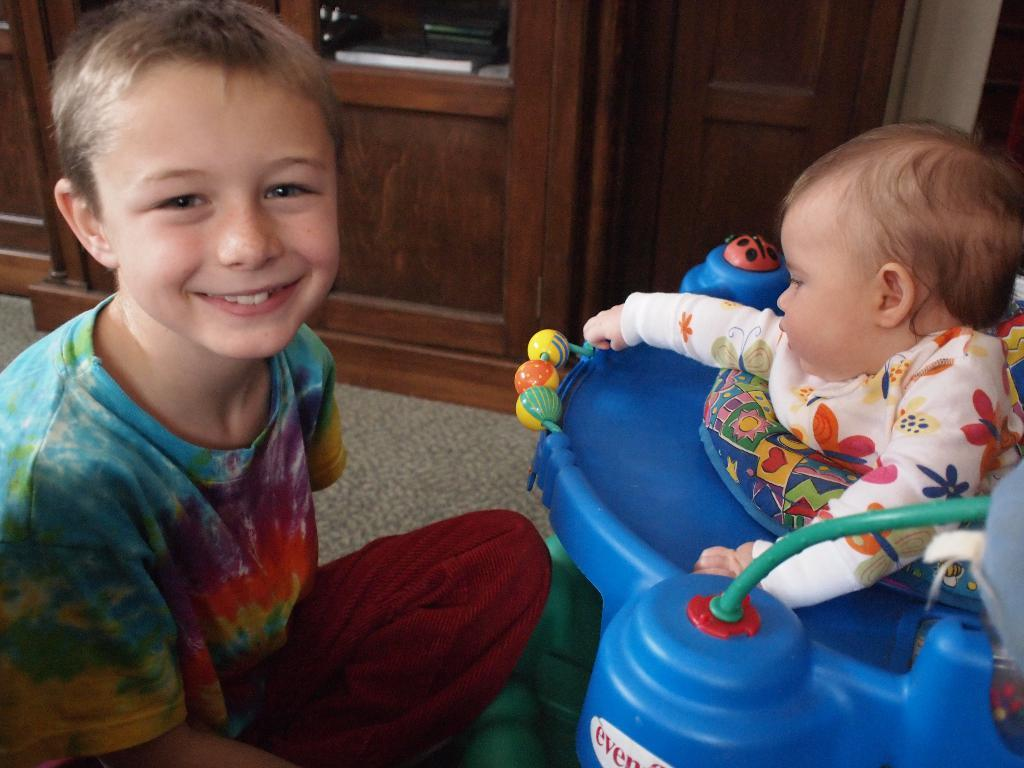What is the position of the boy in the image? The boy is sitting on the floor in the image. What is the other child doing in the image? There is a child in a baby walker in the image. What can be seen on the cupboard in the image? There is a cupboard with objects visible in the image. What type of goose can be seen playing with a toothbrush in the image? There is no goose or toothbrush present in the image. Are there any bushes visible in the image? The provided facts do not mention any bushes in the image. 